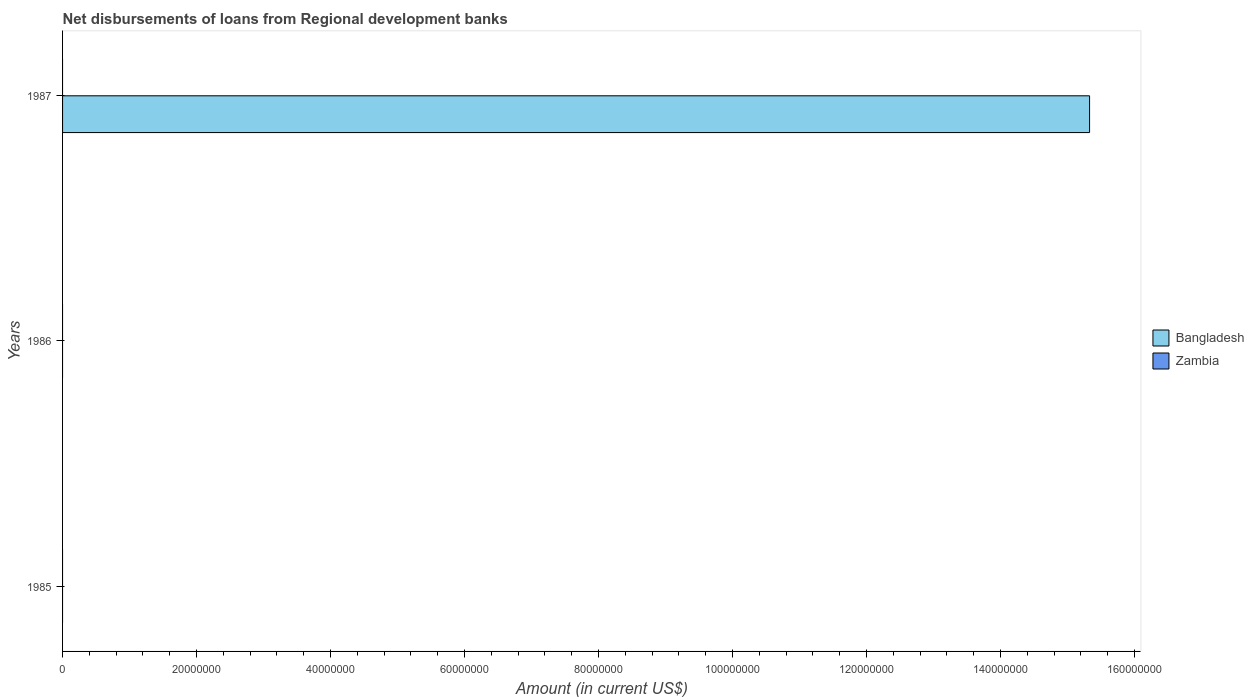Are the number of bars per tick equal to the number of legend labels?
Provide a succinct answer. No. Are the number of bars on each tick of the Y-axis equal?
Offer a terse response. No. How many bars are there on the 3rd tick from the top?
Your answer should be compact. 0. What is the label of the 1st group of bars from the top?
Your answer should be very brief. 1987. Across all years, what is the maximum amount of disbursements of loans from regional development banks in Bangladesh?
Make the answer very short. 1.53e+08. In which year was the amount of disbursements of loans from regional development banks in Bangladesh maximum?
Provide a succinct answer. 1987. What is the total amount of disbursements of loans from regional development banks in Zambia in the graph?
Your answer should be very brief. 0. What is the difference between the amount of disbursements of loans from regional development banks in Bangladesh in 1987 and the amount of disbursements of loans from regional development banks in Zambia in 1986?
Provide a short and direct response. 1.53e+08. What is the average amount of disbursements of loans from regional development banks in Zambia per year?
Provide a short and direct response. 0. In how many years, is the amount of disbursements of loans from regional development banks in Bangladesh greater than 104000000 US$?
Your answer should be very brief. 1. What is the difference between the highest and the lowest amount of disbursements of loans from regional development banks in Bangladesh?
Your answer should be compact. 1.53e+08. In how many years, is the amount of disbursements of loans from regional development banks in Bangladesh greater than the average amount of disbursements of loans from regional development banks in Bangladesh taken over all years?
Offer a terse response. 1. How many bars are there?
Your answer should be very brief. 1. What is the difference between two consecutive major ticks on the X-axis?
Your answer should be compact. 2.00e+07. Does the graph contain any zero values?
Make the answer very short. Yes. Where does the legend appear in the graph?
Offer a very short reply. Center right. What is the title of the graph?
Offer a terse response. Net disbursements of loans from Regional development banks. Does "Montenegro" appear as one of the legend labels in the graph?
Ensure brevity in your answer.  No. What is the label or title of the X-axis?
Offer a very short reply. Amount (in current US$). What is the label or title of the Y-axis?
Offer a very short reply. Years. What is the Amount (in current US$) of Bangladesh in 1985?
Make the answer very short. 0. What is the Amount (in current US$) in Bangladesh in 1987?
Your answer should be compact. 1.53e+08. Across all years, what is the maximum Amount (in current US$) of Bangladesh?
Give a very brief answer. 1.53e+08. Across all years, what is the minimum Amount (in current US$) of Bangladesh?
Offer a very short reply. 0. What is the total Amount (in current US$) in Bangladesh in the graph?
Your answer should be very brief. 1.53e+08. What is the average Amount (in current US$) of Bangladesh per year?
Offer a terse response. 5.11e+07. What is the difference between the highest and the lowest Amount (in current US$) in Bangladesh?
Your response must be concise. 1.53e+08. 